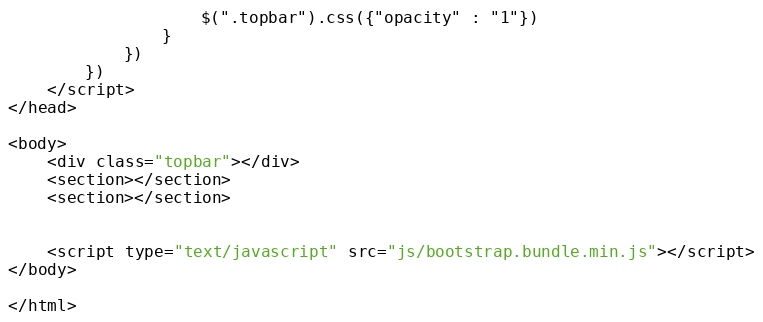Convert code to text. <code><loc_0><loc_0><loc_500><loc_500><_HTML_>                    $(".topbar").css({"opacity" : "1"})
                }
            })
        })
    </script>
</head>

<body>
    <div class="topbar"></div>
    <section></section>
    <section></section>

    
    <script type="text/javascript" src="js/bootstrap.bundle.min.js"></script>
</body>

</html></code> 